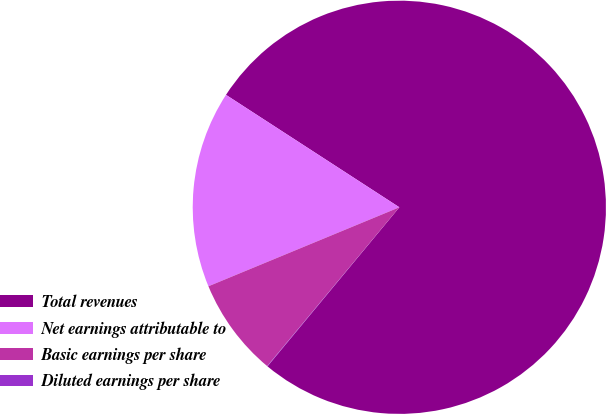<chart> <loc_0><loc_0><loc_500><loc_500><pie_chart><fcel>Total revenues<fcel>Net earnings attributable to<fcel>Basic earnings per share<fcel>Diluted earnings per share<nl><fcel>76.86%<fcel>15.4%<fcel>7.71%<fcel>0.03%<nl></chart> 